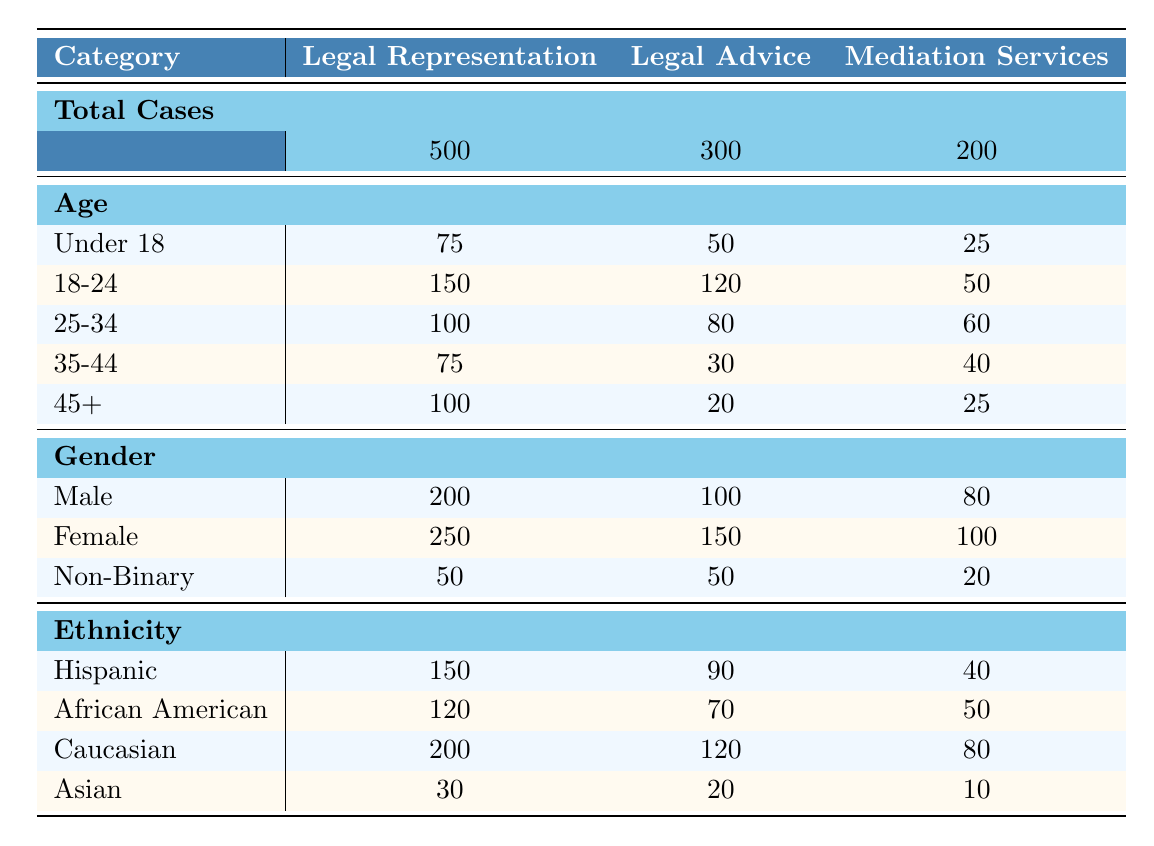What is the total number of Legal Advice cases? From the table, we can see that the total cases under Legal Advice are specified as 300.
Answer: 300 How many clients are aged 18-24 in Mediation Services? Looking at the Mediation Services row under Age, it shows there are 50 clients aged 18-24.
Answer: 50 What percentage of total Legal Representation cases are Male clients? The total cases for Legal Representation is 500, and the number of Male clients is 200. The percentage is (200/500) * 100 = 40%.
Answer: 40% Which category has the highest number of cases and how many? By comparing the Total Cases row for each service, Legal Representation has the highest with 500 cases.
Answer: Legal Representation, 500 What is the total number of Non-Binary clients across all services? The total for Non-Binary clients is the sum of Non-Binary clients from each service: 50 (Legal Representation) + 50 (Legal Advice) + 20 (Mediation Services) = 120.
Answer: 120 Is the number of Hispanic clients in Legal Representation greater than in Legal Advice? The number of Hispanic clients in Legal Representation is 150, while in Legal Advice it's 90. 150 > 90, so the statement is true.
Answer: Yes What is the average age of clients in Legal Advice? To find the average age for Legal Advice, we can use the age groups and their case counts: ((50*1) + (120*2) + (80*3) + (30*4) + (20*5)) / 300. This gives us ((50 + 240 + 240 + 120 + 100) / 300 = 750 / 300 = 2.5) or approximately 25-34.
Answer: Approximately 25-34 How many total cases are there for clients aged 45 and above in all services? For clients aged 45+, we find the counts for each service: 100 (Legal Representation) + 20 (Legal Advice) + 25 (Mediation Services) = 145 total cases.
Answer: 145 Which ethnicity has the least representation in Legal Advice? Under the Ethnicity section for Legal Advice, Asian clients have the least representation with a count of 20.
Answer: Asian, 20 In the Mediation Services category, what is the difference in the number of cases between Female and Male clients? The number of Male clients in Mediation Services is 80, and Female clients are 100. The difference is 100 - 80 = 20.
Answer: 20 